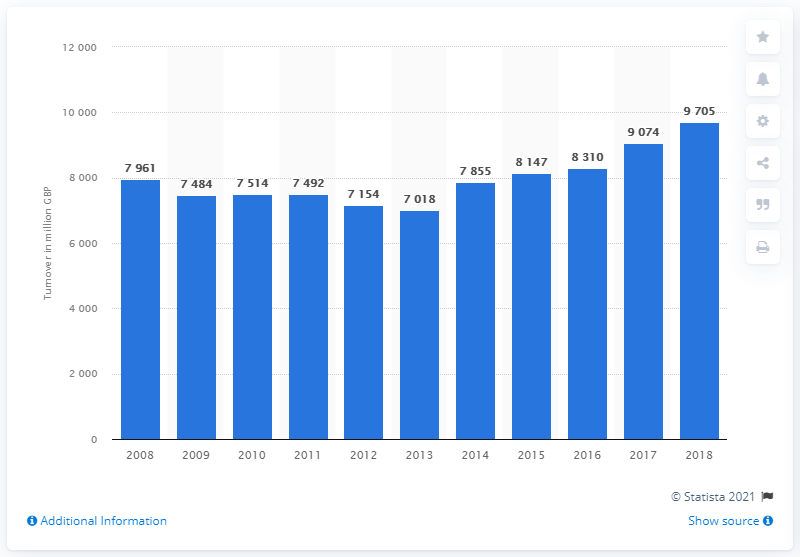Indicate a few pertinent items in this graphic. According to data from 2013, the turnover of retail sales of video games was approximately 7,018 units. In 2008, the retail sales turnover of video games was 7,961. In 2018, the turnover of video game sales was 9,705. 